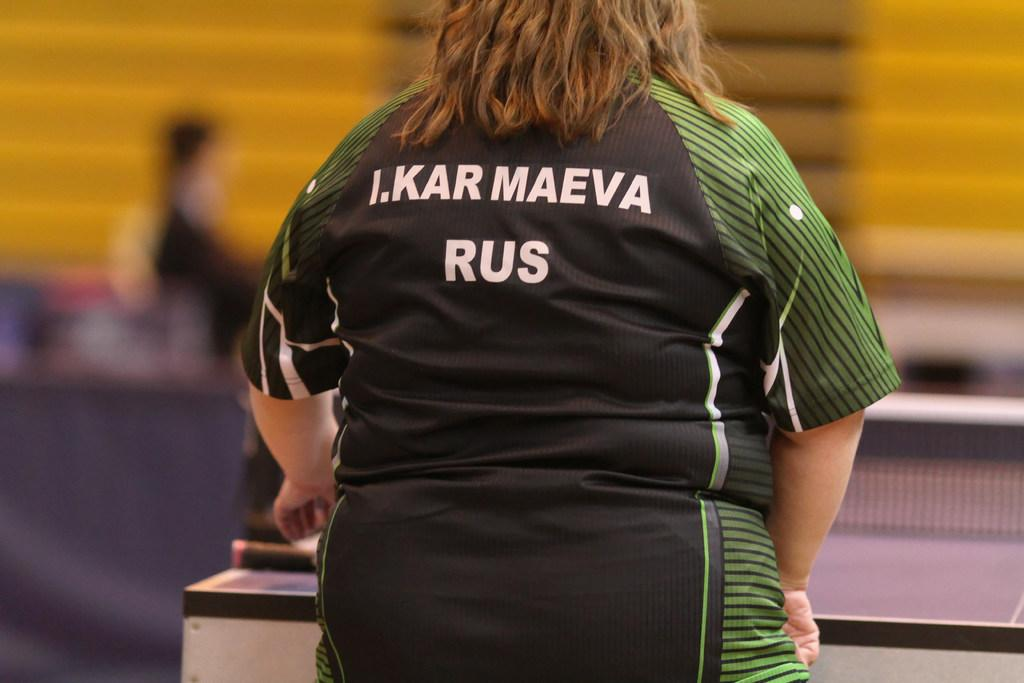Provide a one-sentence caption for the provided image. A women IN a green and black jersey that says I.KARMAEVA RUS. on the back. 